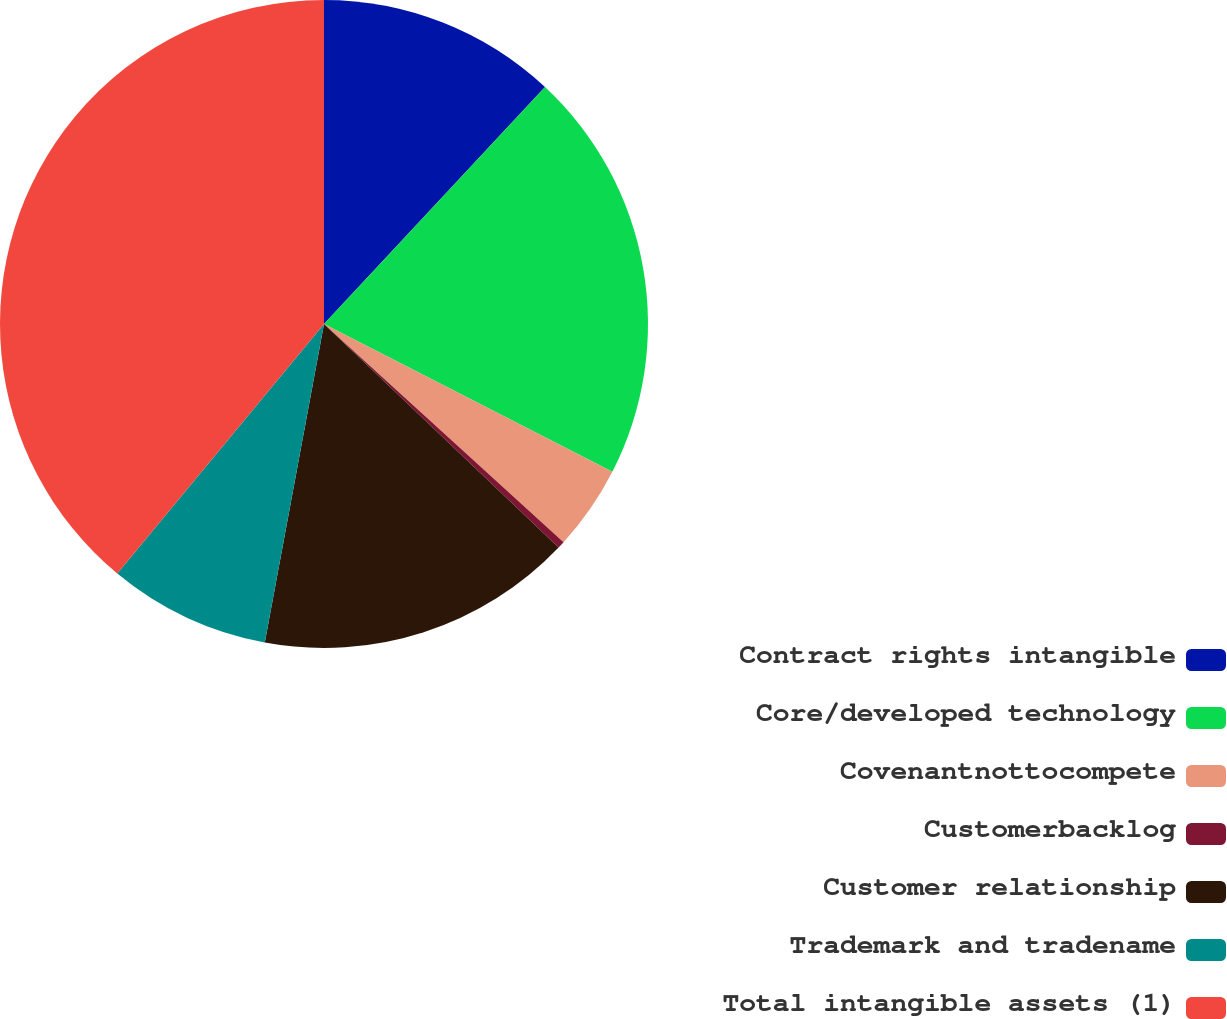<chart> <loc_0><loc_0><loc_500><loc_500><pie_chart><fcel>Contract rights intangible<fcel>Core/developed technology<fcel>Covenantnottocompete<fcel>Customerbacklog<fcel>Customer relationship<fcel>Trademark and tradename<fcel>Total intangible assets (1)<nl><fcel>11.95%<fcel>20.59%<fcel>4.22%<fcel>0.36%<fcel>15.81%<fcel>8.09%<fcel>38.99%<nl></chart> 